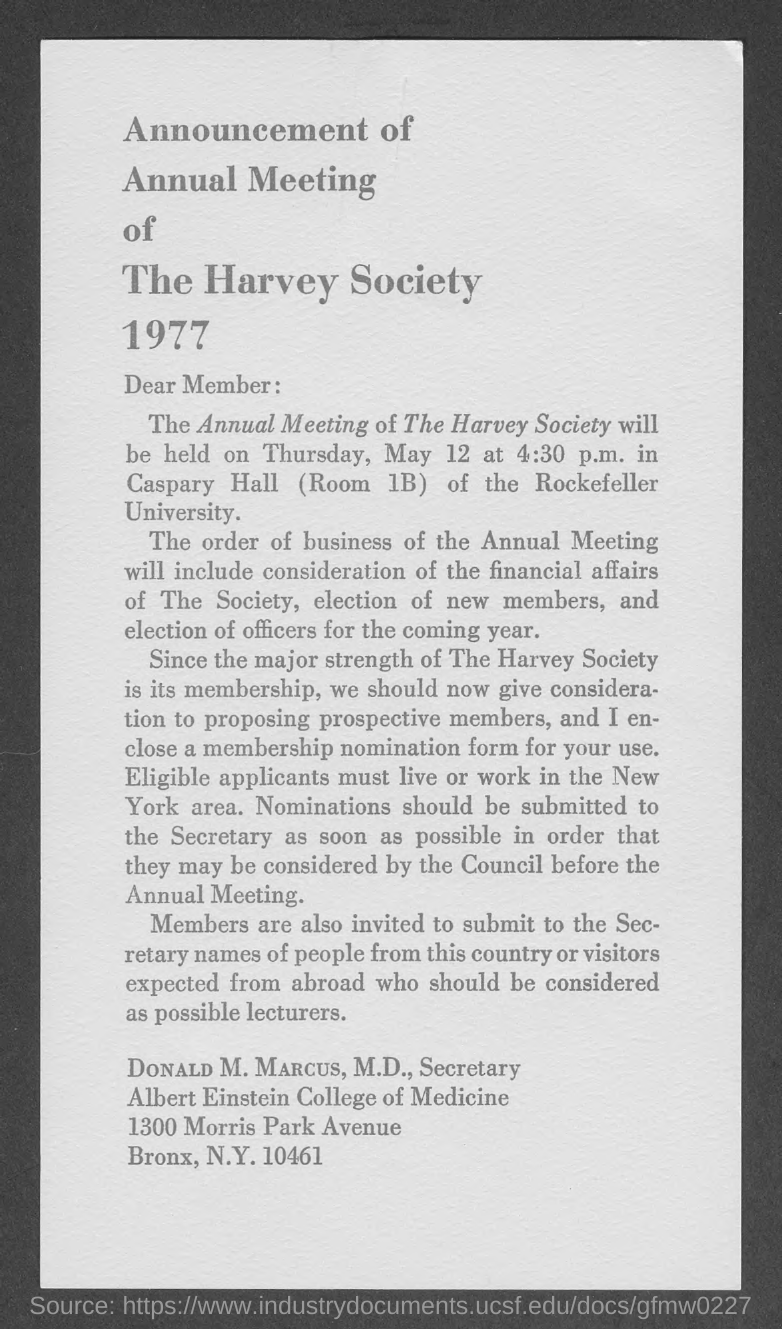What is the year mentioned?
Provide a succinct answer. 1977. What is the time that annual meeting start from?
Your response must be concise. 4:30 p.m. 